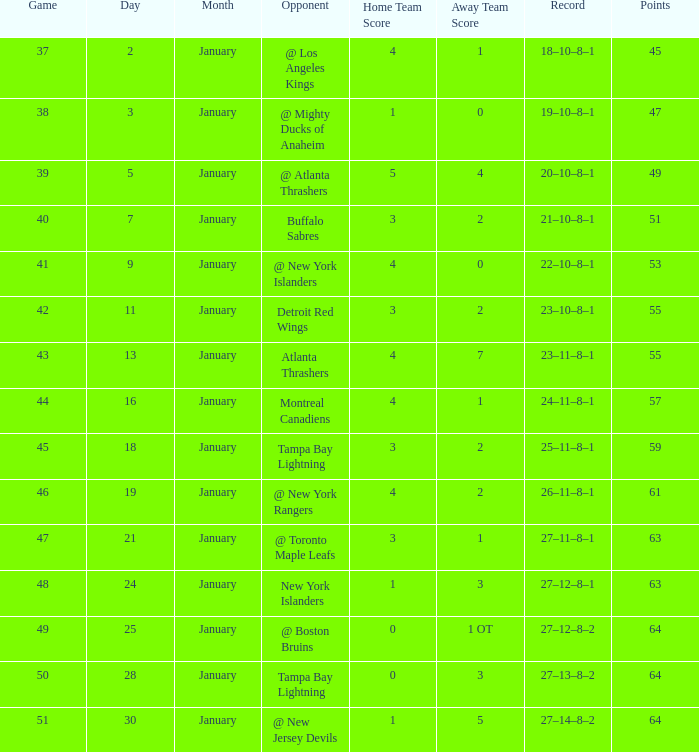Which points feature a score of 4-1, an 18-10-8-1 record, and a january that is more than 2? None. 